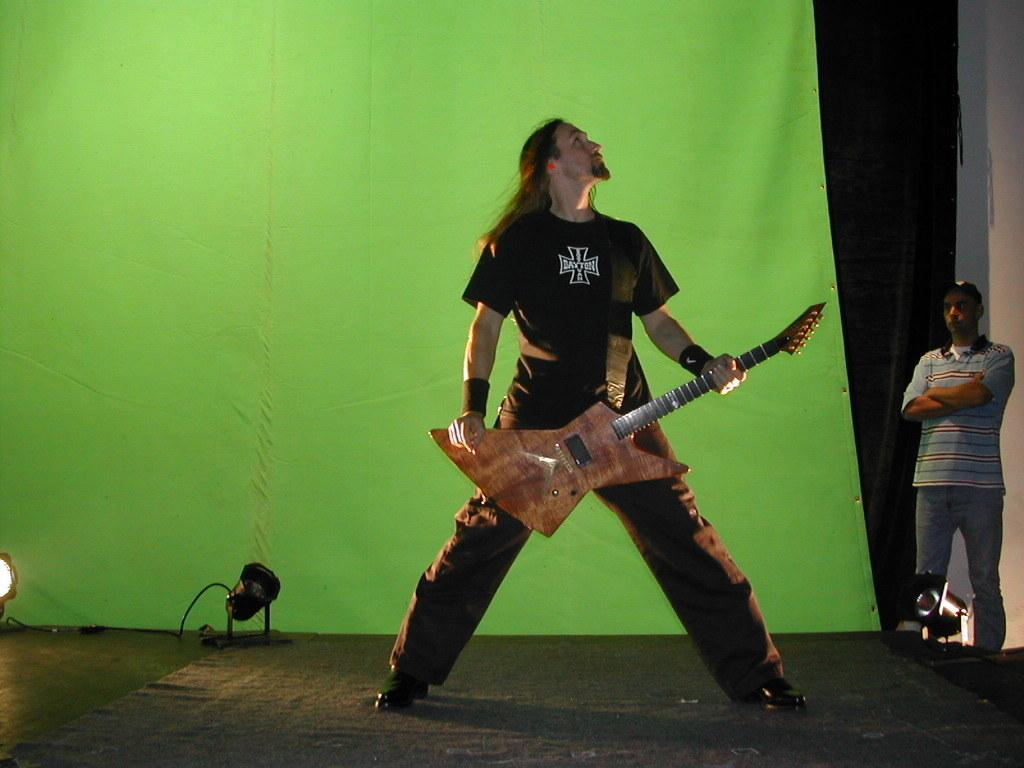What is the man in the image doing? The man is standing in the image and holding a guitar in his hand. Can you describe the second man in the image? There is another man standing in the background. What type of zinc is the man using to play the guitar in the image? There is no zinc present in the image, and the man is not using any zinc to play the guitar. 